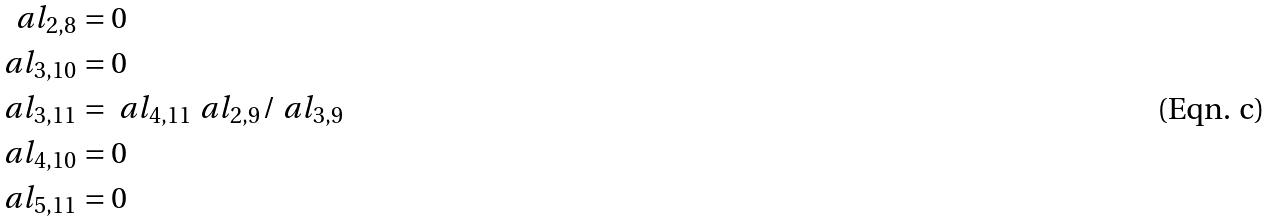<formula> <loc_0><loc_0><loc_500><loc_500>\ a l _ { 2 , 8 } & = 0 \\ \ a l _ { 3 , 1 0 } & = 0 \\ \ a l _ { 3 , 1 1 } & = \ a l _ { 4 , 1 1 } \ a l _ { 2 , 9 } / \ a l _ { 3 , 9 } \\ \ a l _ { 4 , 1 0 } & = 0 \\ \ a l _ { 5 , 1 1 } & = 0</formula> 